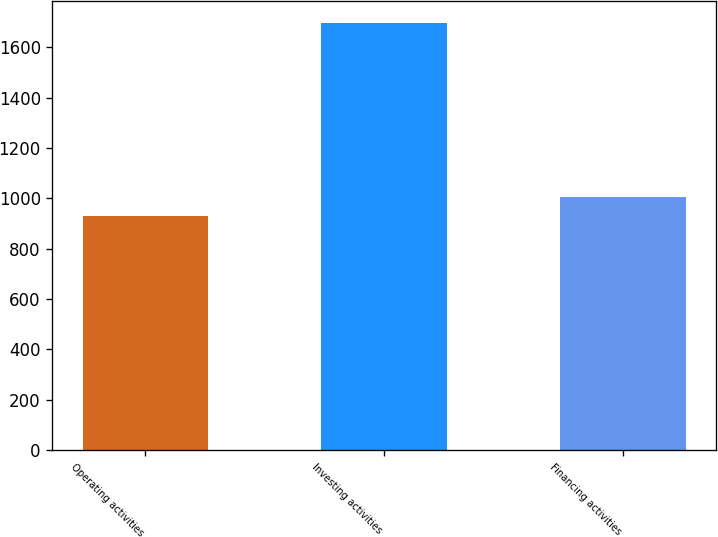<chart> <loc_0><loc_0><loc_500><loc_500><bar_chart><fcel>Operating activities<fcel>Investing activities<fcel>Financing activities<nl><fcel>929<fcel>1698<fcel>1005.9<nl></chart> 